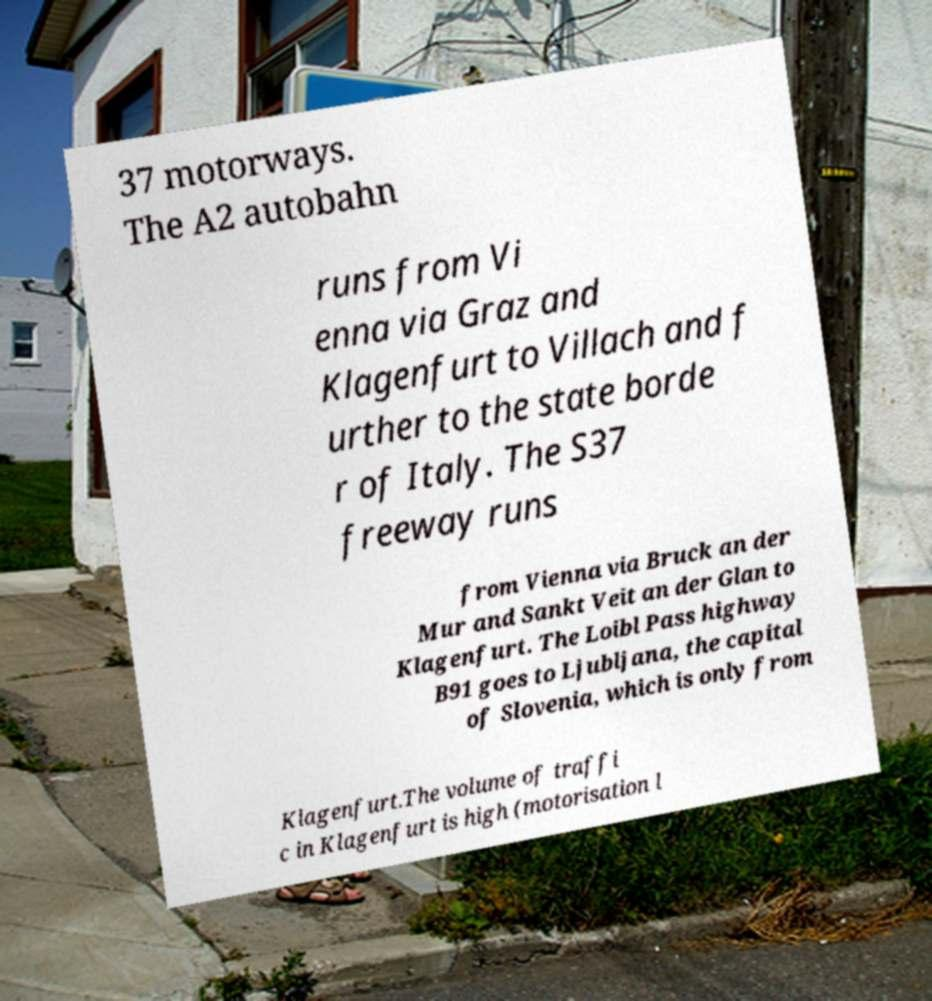Please read and relay the text visible in this image. What does it say? 37 motorways. The A2 autobahn runs from Vi enna via Graz and Klagenfurt to Villach and f urther to the state borde r of Italy. The S37 freeway runs from Vienna via Bruck an der Mur and Sankt Veit an der Glan to Klagenfurt. The Loibl Pass highway B91 goes to Ljubljana, the capital of Slovenia, which is only from Klagenfurt.The volume of traffi c in Klagenfurt is high (motorisation l 